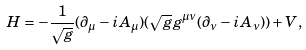<formula> <loc_0><loc_0><loc_500><loc_500>H = - \frac { 1 } { \sqrt { g } } ( \partial _ { \mu } - i A _ { \mu } ) ( \sqrt { g } g ^ { \mu \nu } ( \partial _ { \nu } - i A _ { \nu } ) ) + V ,</formula> 